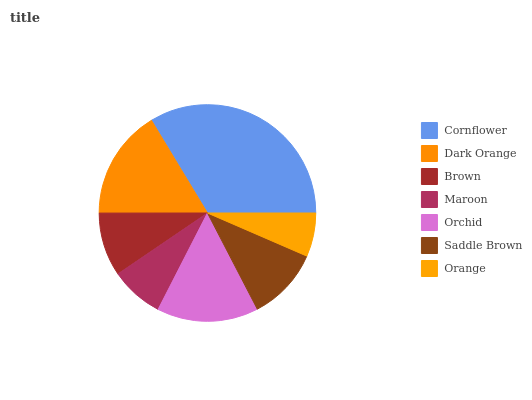Is Orange the minimum?
Answer yes or no. Yes. Is Cornflower the maximum?
Answer yes or no. Yes. Is Dark Orange the minimum?
Answer yes or no. No. Is Dark Orange the maximum?
Answer yes or no. No. Is Cornflower greater than Dark Orange?
Answer yes or no. Yes. Is Dark Orange less than Cornflower?
Answer yes or no. Yes. Is Dark Orange greater than Cornflower?
Answer yes or no. No. Is Cornflower less than Dark Orange?
Answer yes or no. No. Is Saddle Brown the high median?
Answer yes or no. Yes. Is Saddle Brown the low median?
Answer yes or no. Yes. Is Orange the high median?
Answer yes or no. No. Is Orange the low median?
Answer yes or no. No. 